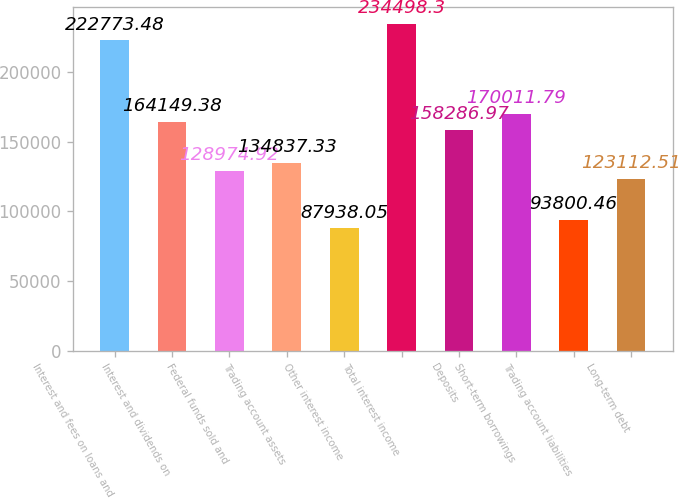<chart> <loc_0><loc_0><loc_500><loc_500><bar_chart><fcel>Interest and fees on loans and<fcel>Interest and dividends on<fcel>Federal funds sold and<fcel>Trading account assets<fcel>Other interest income<fcel>Total interest income<fcel>Deposits<fcel>Short-term borrowings<fcel>Trading account liabilities<fcel>Long-term debt<nl><fcel>222773<fcel>164149<fcel>128975<fcel>134837<fcel>87938.1<fcel>234498<fcel>158287<fcel>170012<fcel>93800.5<fcel>123113<nl></chart> 